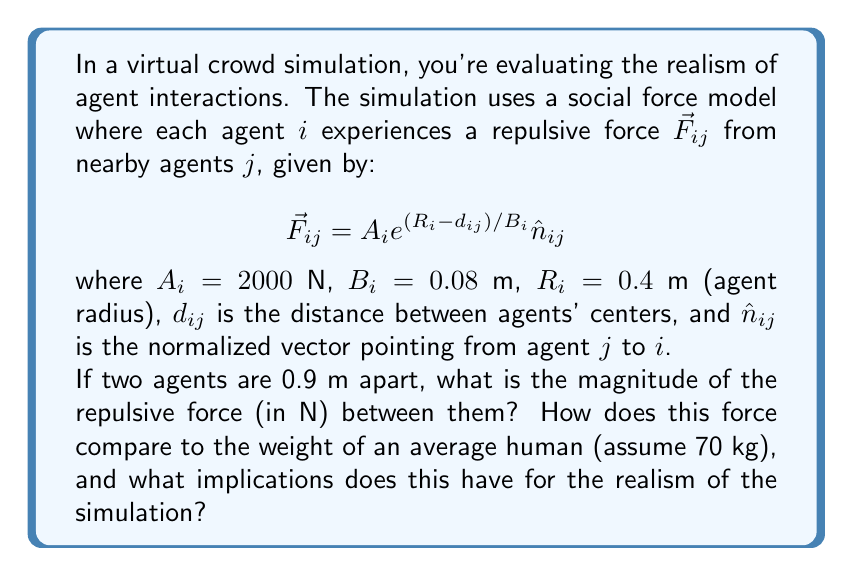Provide a solution to this math problem. Let's approach this step-by-step:

1) We're given:
   $A_i = 2000$ N
   $B_i = 0.08$ m
   $R_i = 0.4$ m
   $d_{ij} = 0.9$ m

2) We need to calculate $\vec{F}_{ij} = A_i e^{(R_i - d_{ij}) / B_i} \hat{n}_{ij}$

3) First, let's calculate the exponent:
   $\frac{R_i - d_{ij}}{B_i} = \frac{0.4 - 0.9}{0.08} = -\frac{0.5}{0.08} = -6.25$

4) Now we can calculate the magnitude of the force:
   $|\vec{F}_{ij}| = A_i e^{(R_i - d_{ij}) / B_i} = 2000 \cdot e^{-6.25} \approx 3.86$ N

5) To compare with human weight:
   Weight = mass * gravity = 70 kg * 9.81 m/s² ≈ 686.7 N

6) The repulsive force (3.86 N) is about 0.56% of the average human weight (686.7 N).

Implications for realism:
- The force is relatively small compared to human weight, which is realistic as people don't typically exert large forces on each other at this distance.
- However, it's still significant enough to influence movement, which could create natural-looking avoidance behaviors.
- The exponential decay ensures that the force increases rapidly as agents get closer, which mimics how people react more strongly to very close intrusions of personal space.
- For even more realism, the model could incorporate variations in $A_i$ and $B_i$ based on cultural norms or individual characteristics.
Answer: 3.86 N; 0.56% of average human weight; realistic for subtle interactions, supports natural avoidance behaviors 